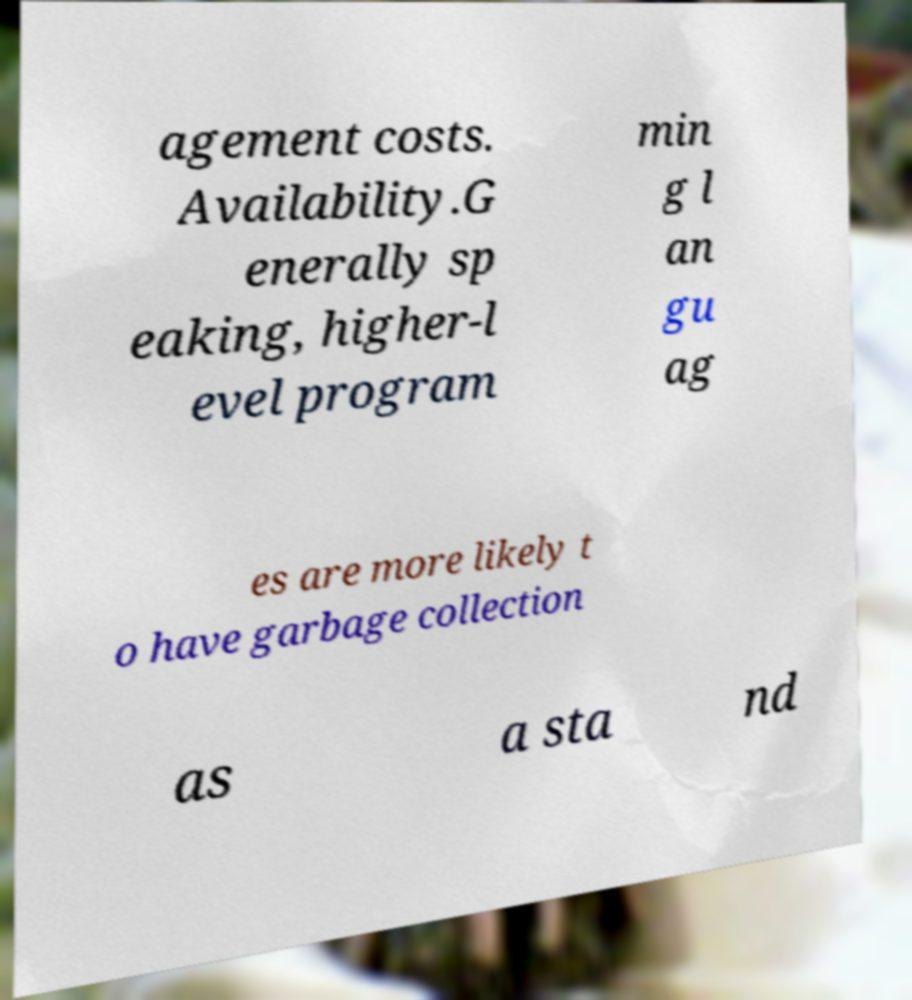Can you accurately transcribe the text from the provided image for me? agement costs. Availability.G enerally sp eaking, higher-l evel program min g l an gu ag es are more likely t o have garbage collection as a sta nd 